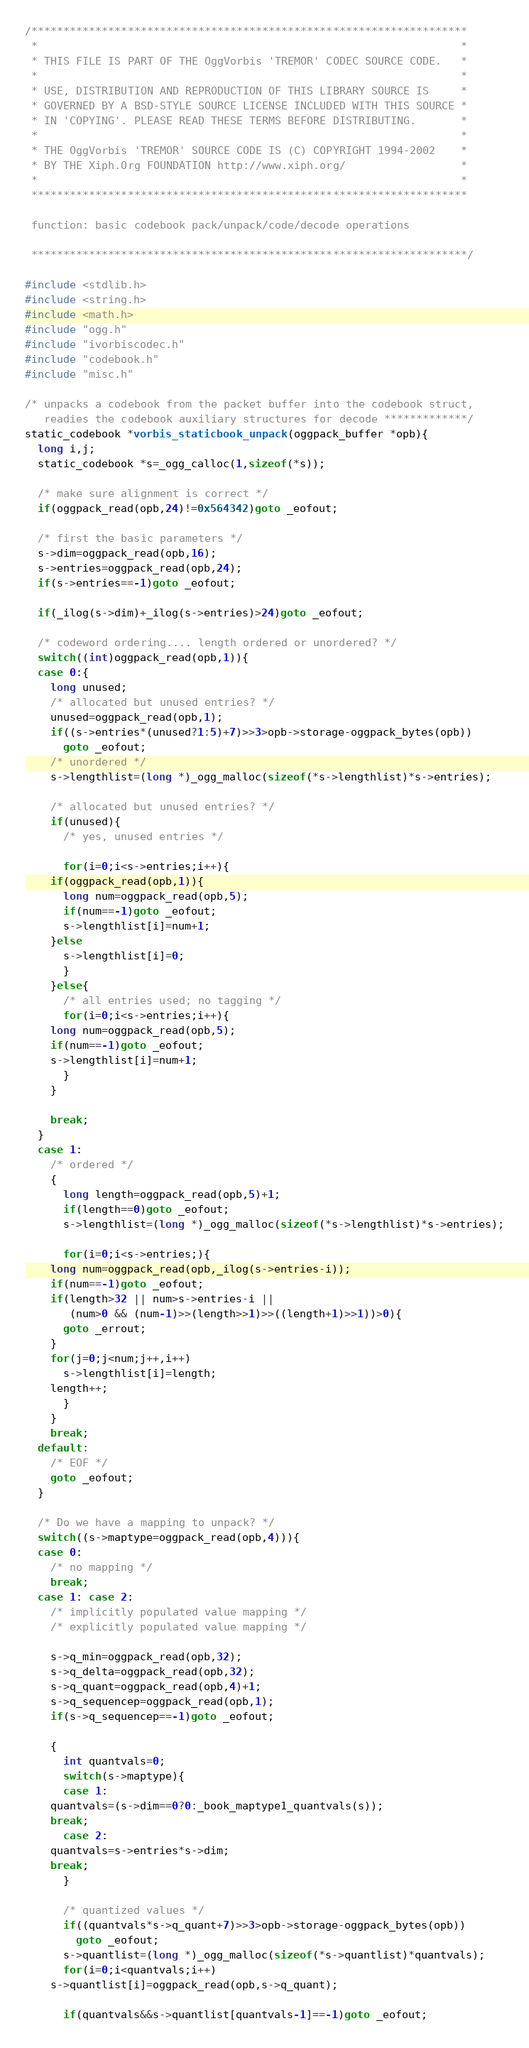Convert code to text. <code><loc_0><loc_0><loc_500><loc_500><_C_>/********************************************************************
 *                                                                  *
 * THIS FILE IS PART OF THE OggVorbis 'TREMOR' CODEC SOURCE CODE.   *
 *                                                                  *
 * USE, DISTRIBUTION AND REPRODUCTION OF THIS LIBRARY SOURCE IS     *
 * GOVERNED BY A BSD-STYLE SOURCE LICENSE INCLUDED WITH THIS SOURCE *
 * IN 'COPYING'. PLEASE READ THESE TERMS BEFORE DISTRIBUTING.       *
 *                                                                  *
 * THE OggVorbis 'TREMOR' SOURCE CODE IS (C) COPYRIGHT 1994-2002    *
 * BY THE Xiph.Org FOUNDATION http://www.xiph.org/                  *
 *                                                                  *
 ********************************************************************

 function: basic codebook pack/unpack/code/decode operations

 ********************************************************************/

#include <stdlib.h>
#include <string.h>
#include <math.h>
#include "ogg.h"
#include "ivorbiscodec.h"
#include "codebook.h"
#include "misc.h"

/* unpacks a codebook from the packet buffer into the codebook struct,
   readies the codebook auxiliary structures for decode *************/
static_codebook *vorbis_staticbook_unpack(oggpack_buffer *opb){
  long i,j;
  static_codebook *s=_ogg_calloc(1,sizeof(*s));

  /* make sure alignment is correct */
  if(oggpack_read(opb,24)!=0x564342)goto _eofout;

  /* first the basic parameters */
  s->dim=oggpack_read(opb,16);
  s->entries=oggpack_read(opb,24);
  if(s->entries==-1)goto _eofout;

  if(_ilog(s->dim)+_ilog(s->entries)>24)goto _eofout;

  /* codeword ordering.... length ordered or unordered? */
  switch((int)oggpack_read(opb,1)){
  case 0:{
    long unused;
    /* allocated but unused entries? */
    unused=oggpack_read(opb,1);
    if((s->entries*(unused?1:5)+7)>>3>opb->storage-oggpack_bytes(opb))
      goto _eofout;
    /* unordered */
    s->lengthlist=(long *)_ogg_malloc(sizeof(*s->lengthlist)*s->entries);

    /* allocated but unused entries? */
    if(unused){
      /* yes, unused entries */

      for(i=0;i<s->entries;i++){
	if(oggpack_read(opb,1)){
	  long num=oggpack_read(opb,5);
	  if(num==-1)goto _eofout;
	  s->lengthlist[i]=num+1;
	}else
	  s->lengthlist[i]=0;
      }
    }else{
      /* all entries used; no tagging */
      for(i=0;i<s->entries;i++){
	long num=oggpack_read(opb,5);
	if(num==-1)goto _eofout;
	s->lengthlist[i]=num+1;
      }
    }
    
    break;
  }
  case 1:
    /* ordered */
    {
      long length=oggpack_read(opb,5)+1;
      if(length==0)goto _eofout;
      s->lengthlist=(long *)_ogg_malloc(sizeof(*s->lengthlist)*s->entries);

      for(i=0;i<s->entries;){
	long num=oggpack_read(opb,_ilog(s->entries-i));
	if(num==-1)goto _eofout;
	if(length>32 || num>s->entries-i ||
	   (num>0 && (num-1)>>(length>>1)>>((length+1)>>1))>0){
	  goto _errout;
	}
	for(j=0;j<num;j++,i++)
	  s->lengthlist[i]=length;
	length++;
      }
    }
    break;
  default:
    /* EOF */
    goto _eofout;
  }
  
  /* Do we have a mapping to unpack? */
  switch((s->maptype=oggpack_read(opb,4))){
  case 0:
    /* no mapping */
    break;
  case 1: case 2:
    /* implicitly populated value mapping */
    /* explicitly populated value mapping */

    s->q_min=oggpack_read(opb,32);
    s->q_delta=oggpack_read(opb,32);
    s->q_quant=oggpack_read(opb,4)+1;
    s->q_sequencep=oggpack_read(opb,1);
    if(s->q_sequencep==-1)goto _eofout;

    {
      int quantvals=0;
      switch(s->maptype){
      case 1:
	quantvals=(s->dim==0?0:_book_maptype1_quantvals(s));
	break;
      case 2:
	quantvals=s->entries*s->dim;
	break;
      }
      
      /* quantized values */
      if((quantvals*s->q_quant+7)>>3>opb->storage-oggpack_bytes(opb))
        goto _eofout;
      s->quantlist=(long *)_ogg_malloc(sizeof(*s->quantlist)*quantvals);
      for(i=0;i<quantvals;i++)
	s->quantlist[i]=oggpack_read(opb,s->q_quant);
      
      if(quantvals&&s->quantlist[quantvals-1]==-1)goto _eofout;</code> 